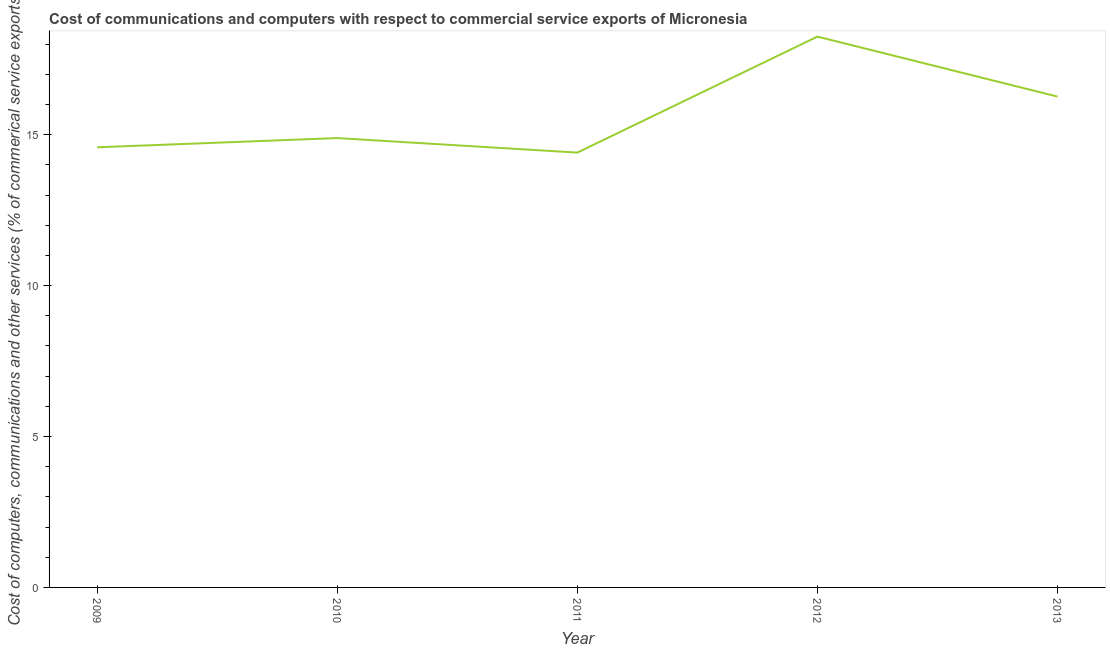What is the  computer and other services in 2012?
Ensure brevity in your answer.  18.25. Across all years, what is the maximum  computer and other services?
Provide a short and direct response. 18.25. Across all years, what is the minimum cost of communications?
Your answer should be compact. 14.41. In which year was the cost of communications maximum?
Give a very brief answer. 2012. In which year was the  computer and other services minimum?
Give a very brief answer. 2011. What is the sum of the cost of communications?
Your answer should be very brief. 78.39. What is the difference between the cost of communications in 2009 and 2013?
Ensure brevity in your answer.  -1.68. What is the average cost of communications per year?
Your response must be concise. 15.68. What is the median cost of communications?
Make the answer very short. 14.89. Do a majority of the years between 2009 and 2012 (inclusive) have cost of communications greater than 7 %?
Your response must be concise. Yes. What is the ratio of the cost of communications in 2010 to that in 2011?
Offer a terse response. 1.03. Is the cost of communications in 2009 less than that in 2010?
Your answer should be compact. Yes. Is the difference between the cost of communications in 2009 and 2013 greater than the difference between any two years?
Give a very brief answer. No. What is the difference between the highest and the second highest  computer and other services?
Make the answer very short. 1.99. What is the difference between the highest and the lowest  computer and other services?
Your response must be concise. 3.84. In how many years, is the  computer and other services greater than the average  computer and other services taken over all years?
Keep it short and to the point. 2. How many lines are there?
Make the answer very short. 1. Are the values on the major ticks of Y-axis written in scientific E-notation?
Ensure brevity in your answer.  No. Does the graph contain any zero values?
Your answer should be very brief. No. What is the title of the graph?
Provide a succinct answer. Cost of communications and computers with respect to commercial service exports of Micronesia. What is the label or title of the X-axis?
Keep it short and to the point. Year. What is the label or title of the Y-axis?
Your answer should be very brief. Cost of computers, communications and other services (% of commerical service exports). What is the Cost of computers, communications and other services (% of commerical service exports) of 2009?
Give a very brief answer. 14.58. What is the Cost of computers, communications and other services (% of commerical service exports) in 2010?
Provide a succinct answer. 14.89. What is the Cost of computers, communications and other services (% of commerical service exports) in 2011?
Give a very brief answer. 14.41. What is the Cost of computers, communications and other services (% of commerical service exports) in 2012?
Provide a short and direct response. 18.25. What is the Cost of computers, communications and other services (% of commerical service exports) of 2013?
Give a very brief answer. 16.26. What is the difference between the Cost of computers, communications and other services (% of commerical service exports) in 2009 and 2010?
Offer a very short reply. -0.31. What is the difference between the Cost of computers, communications and other services (% of commerical service exports) in 2009 and 2011?
Give a very brief answer. 0.18. What is the difference between the Cost of computers, communications and other services (% of commerical service exports) in 2009 and 2012?
Give a very brief answer. -3.67. What is the difference between the Cost of computers, communications and other services (% of commerical service exports) in 2009 and 2013?
Offer a terse response. -1.68. What is the difference between the Cost of computers, communications and other services (% of commerical service exports) in 2010 and 2011?
Your response must be concise. 0.48. What is the difference between the Cost of computers, communications and other services (% of commerical service exports) in 2010 and 2012?
Offer a terse response. -3.36. What is the difference between the Cost of computers, communications and other services (% of commerical service exports) in 2010 and 2013?
Keep it short and to the point. -1.37. What is the difference between the Cost of computers, communications and other services (% of commerical service exports) in 2011 and 2012?
Ensure brevity in your answer.  -3.84. What is the difference between the Cost of computers, communications and other services (% of commerical service exports) in 2011 and 2013?
Ensure brevity in your answer.  -1.86. What is the difference between the Cost of computers, communications and other services (% of commerical service exports) in 2012 and 2013?
Ensure brevity in your answer.  1.99. What is the ratio of the Cost of computers, communications and other services (% of commerical service exports) in 2009 to that in 2010?
Provide a succinct answer. 0.98. What is the ratio of the Cost of computers, communications and other services (% of commerical service exports) in 2009 to that in 2011?
Offer a terse response. 1.01. What is the ratio of the Cost of computers, communications and other services (% of commerical service exports) in 2009 to that in 2012?
Keep it short and to the point. 0.8. What is the ratio of the Cost of computers, communications and other services (% of commerical service exports) in 2009 to that in 2013?
Offer a very short reply. 0.9. What is the ratio of the Cost of computers, communications and other services (% of commerical service exports) in 2010 to that in 2011?
Your answer should be very brief. 1.03. What is the ratio of the Cost of computers, communications and other services (% of commerical service exports) in 2010 to that in 2012?
Provide a short and direct response. 0.82. What is the ratio of the Cost of computers, communications and other services (% of commerical service exports) in 2010 to that in 2013?
Your answer should be very brief. 0.92. What is the ratio of the Cost of computers, communications and other services (% of commerical service exports) in 2011 to that in 2012?
Offer a very short reply. 0.79. What is the ratio of the Cost of computers, communications and other services (% of commerical service exports) in 2011 to that in 2013?
Make the answer very short. 0.89. What is the ratio of the Cost of computers, communications and other services (% of commerical service exports) in 2012 to that in 2013?
Ensure brevity in your answer.  1.12. 